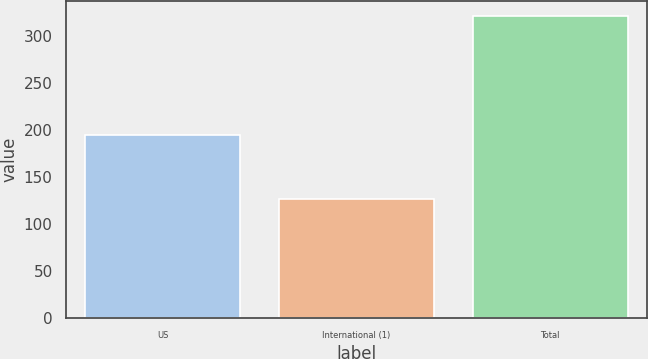<chart> <loc_0><loc_0><loc_500><loc_500><bar_chart><fcel>US<fcel>International (1)<fcel>Total<nl><fcel>195<fcel>126<fcel>321<nl></chart> 